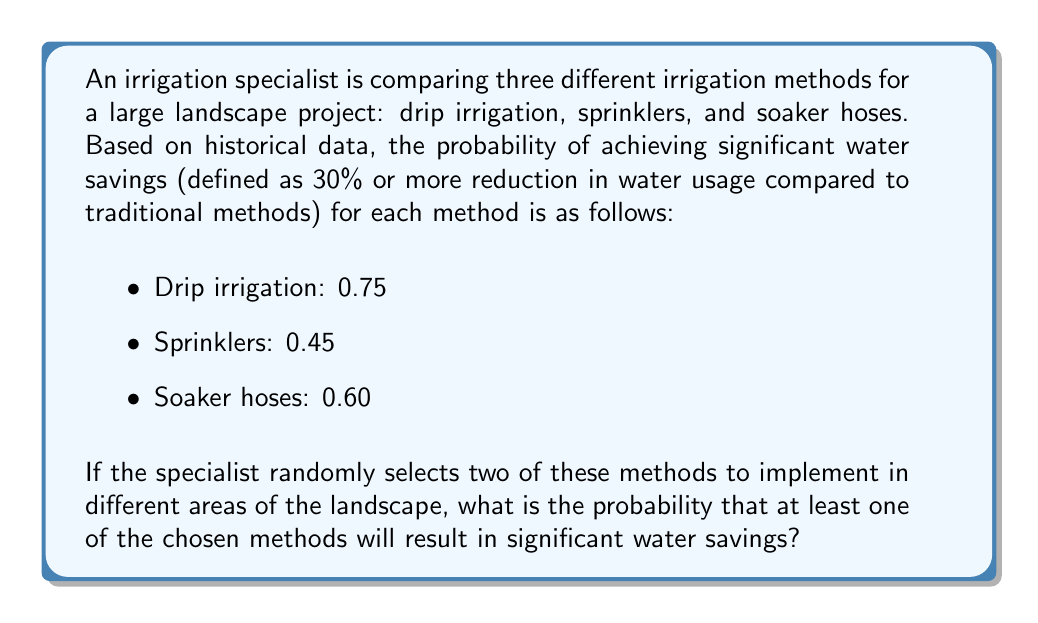Help me with this question. To solve this problem, we'll use the concept of probability of at least one event occurring.

Let's approach this step-by-step:

1) First, we need to calculate the probability of selecting two methods out of three. This is a combination problem, but since we're considering all possible pairs, we don't need to calculate this explicitly.

2) The possible pairs are:
   - Drip irrigation and Sprinklers
   - Drip irrigation and Soaker hoses
   - Sprinklers and Soaker hoses

3) Now, let's calculate the probability that at least one method results in significant water savings. It's easier to calculate the probability of the complement event (neither method results in savings) and then subtract from 1.

4) For each pair:

   a) Drip irrigation and Sprinklers:
      $P(\text{neither saves}) = (1-0.75)(1-0.45) = 0.25 \times 0.55 = 0.1375$
      $P(\text{at least one saves}) = 1 - 0.1375 = 0.8625$

   b) Drip irrigation and Soaker hoses:
      $P(\text{neither saves}) = (1-0.75)(1-0.60) = 0.25 \times 0.40 = 0.1000$
      $P(\text{at least one saves}) = 1 - 0.1000 = 0.9000$

   c) Sprinklers and Soaker hoses:
      $P(\text{neither saves}) = (1-0.45)(1-0.60) = 0.55 \times 0.40 = 0.2200$
      $P(\text{at least one saves}) = 1 - 0.2200 = 0.7800$

5) The overall probability is the average of these three probabilities:

   $$P(\text{at least one saves}) = \frac{0.8625 + 0.9000 + 0.7800}{3} = \frac{2.5425}{3} = 0.8475$$

Therefore, the probability that at least one of the chosen methods will result in significant water savings is 0.8475 or about 84.75%.
Answer: 0.8475 or 84.75% 